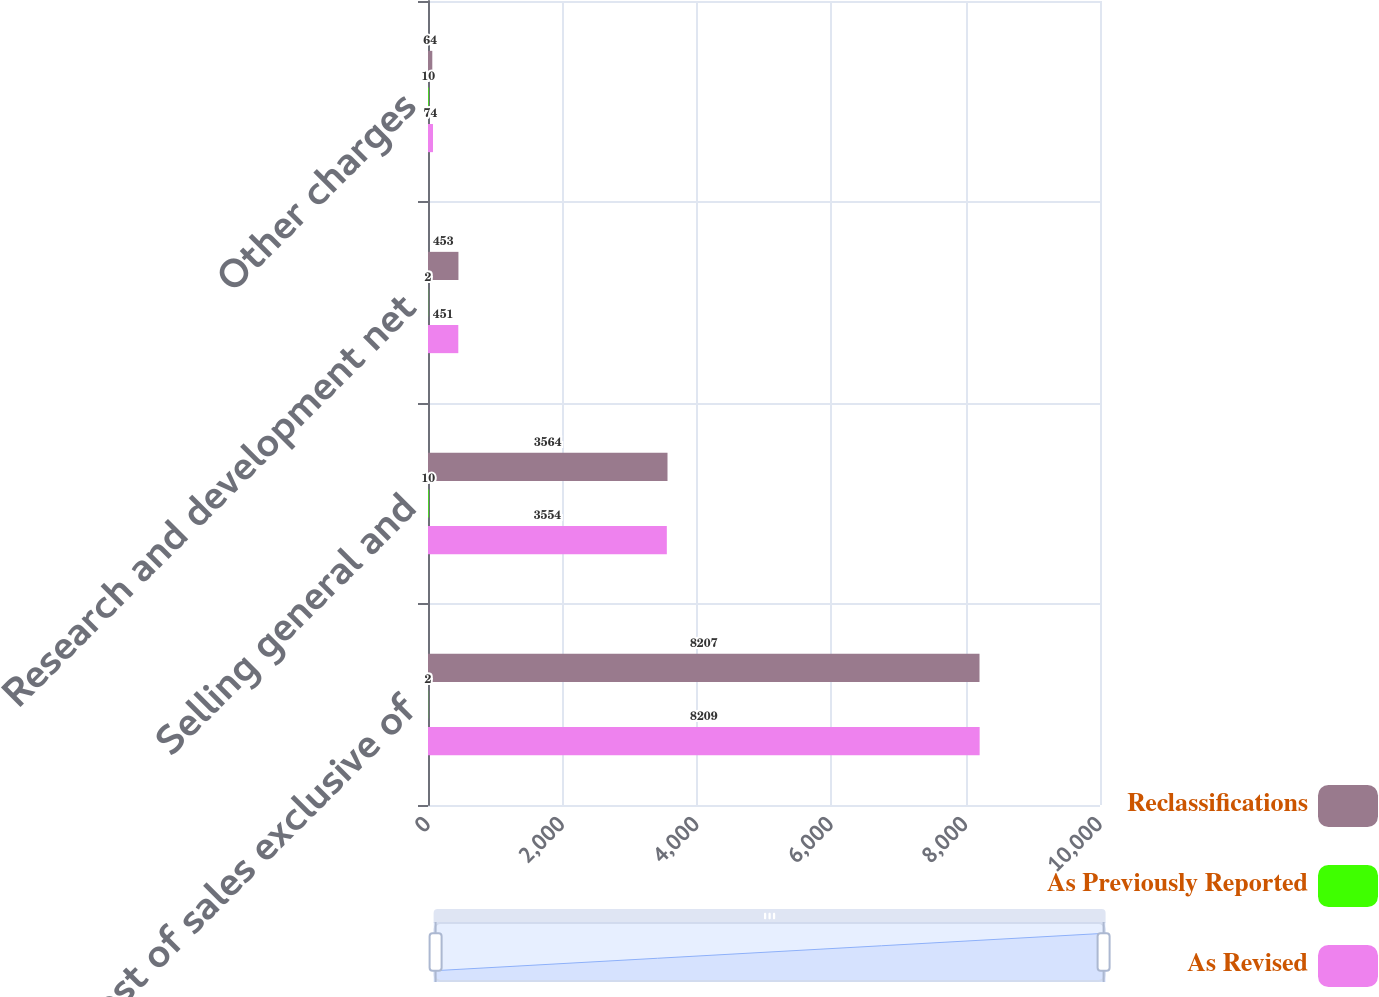Convert chart. <chart><loc_0><loc_0><loc_500><loc_500><stacked_bar_chart><ecel><fcel>Cost of sales exclusive of<fcel>Selling general and<fcel>Research and development net<fcel>Other charges<nl><fcel>Reclassifications<fcel>8207<fcel>3564<fcel>453<fcel>64<nl><fcel>As Previously Reported<fcel>2<fcel>10<fcel>2<fcel>10<nl><fcel>As Revised<fcel>8209<fcel>3554<fcel>451<fcel>74<nl></chart> 